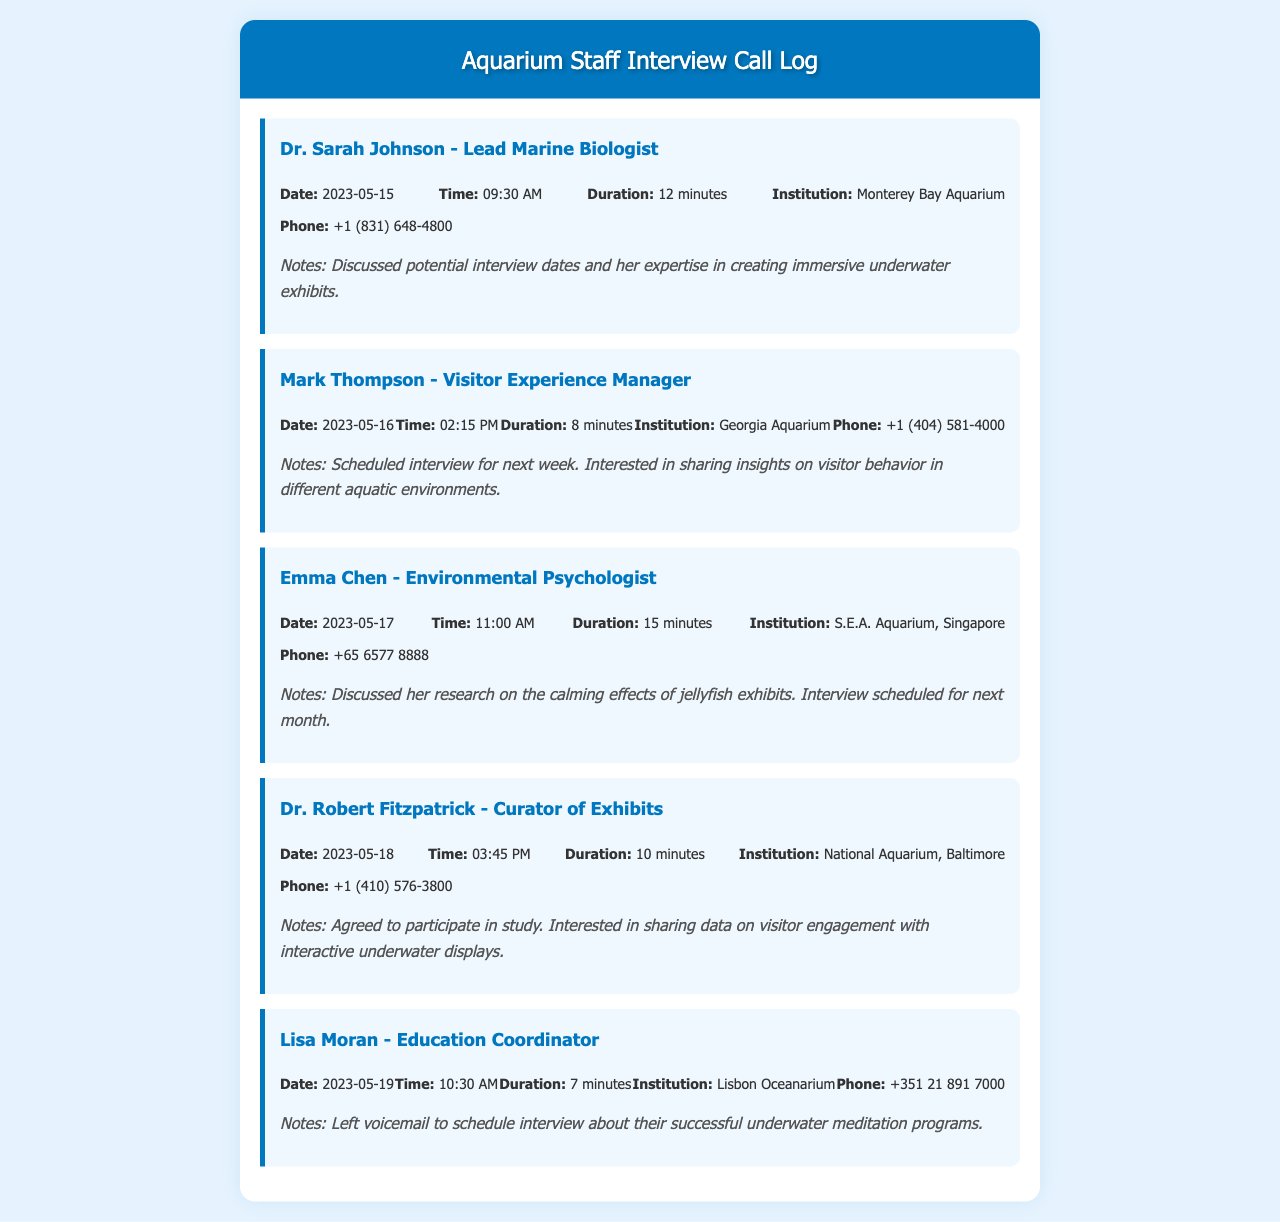What is the name of the Lead Marine Biologist? The document states that Dr. Sarah Johnson is the Lead Marine Biologist.
Answer: Dr. Sarah Johnson What is the phone number of the Visitor Experience Manager? The phone number listed for Mark Thompson, the Visitor Experience Manager, is +1 (404) 581-4000.
Answer: +1 (404) 581-4000 What date is the interview with Emma Chen scheduled for? The document mentions that the interview with Emma Chen is scheduled for next month, after discussing her research.
Answer: Next month How long was the call with Dr. Robert Fitzpatrick? The duration of the call with Dr. Robert Fitzpatrick is specifically mentioned as 10 minutes.
Answer: 10 minutes What institution does Lisa Moran work for? The document specifies that Lisa Moran is from the Lisbon Oceanarium.
Answer: Lisbon Oceanarium What topic did Dr. Sarah Johnson discuss during the call? The notes indicate that Dr. Sarah Johnson discussed her expertise in creating immersive underwater exhibits.
Answer: Creating immersive underwater exhibits Who is interested in sharing data on visitor engagement? Dr. Robert Fitzpatrick is noted as being interested in sharing data on visitor engagement with interactive underwater displays.
Answer: Dr. Robert Fitzpatrick When was the call with Mark Thompson made? The call with Mark Thompson was made on May 16, 2023, as indicated in the document.
Answer: 2023-05-16 What is the total number of staff members listed in the call log? The document lists a total of five staff members that were called during scheduling interviews.
Answer: Five 